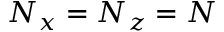<formula> <loc_0><loc_0><loc_500><loc_500>N _ { x } = N _ { z } = N</formula> 